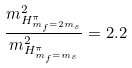<formula> <loc_0><loc_0><loc_500><loc_500>\frac { m ^ { 2 } _ { H ^ { \pi } _ { m _ { f } = 2 m _ { s } } } } { m ^ { 2 } _ { H ^ { \pi } _ { m _ { f } = m _ { s } } } } = 2 . 2</formula> 